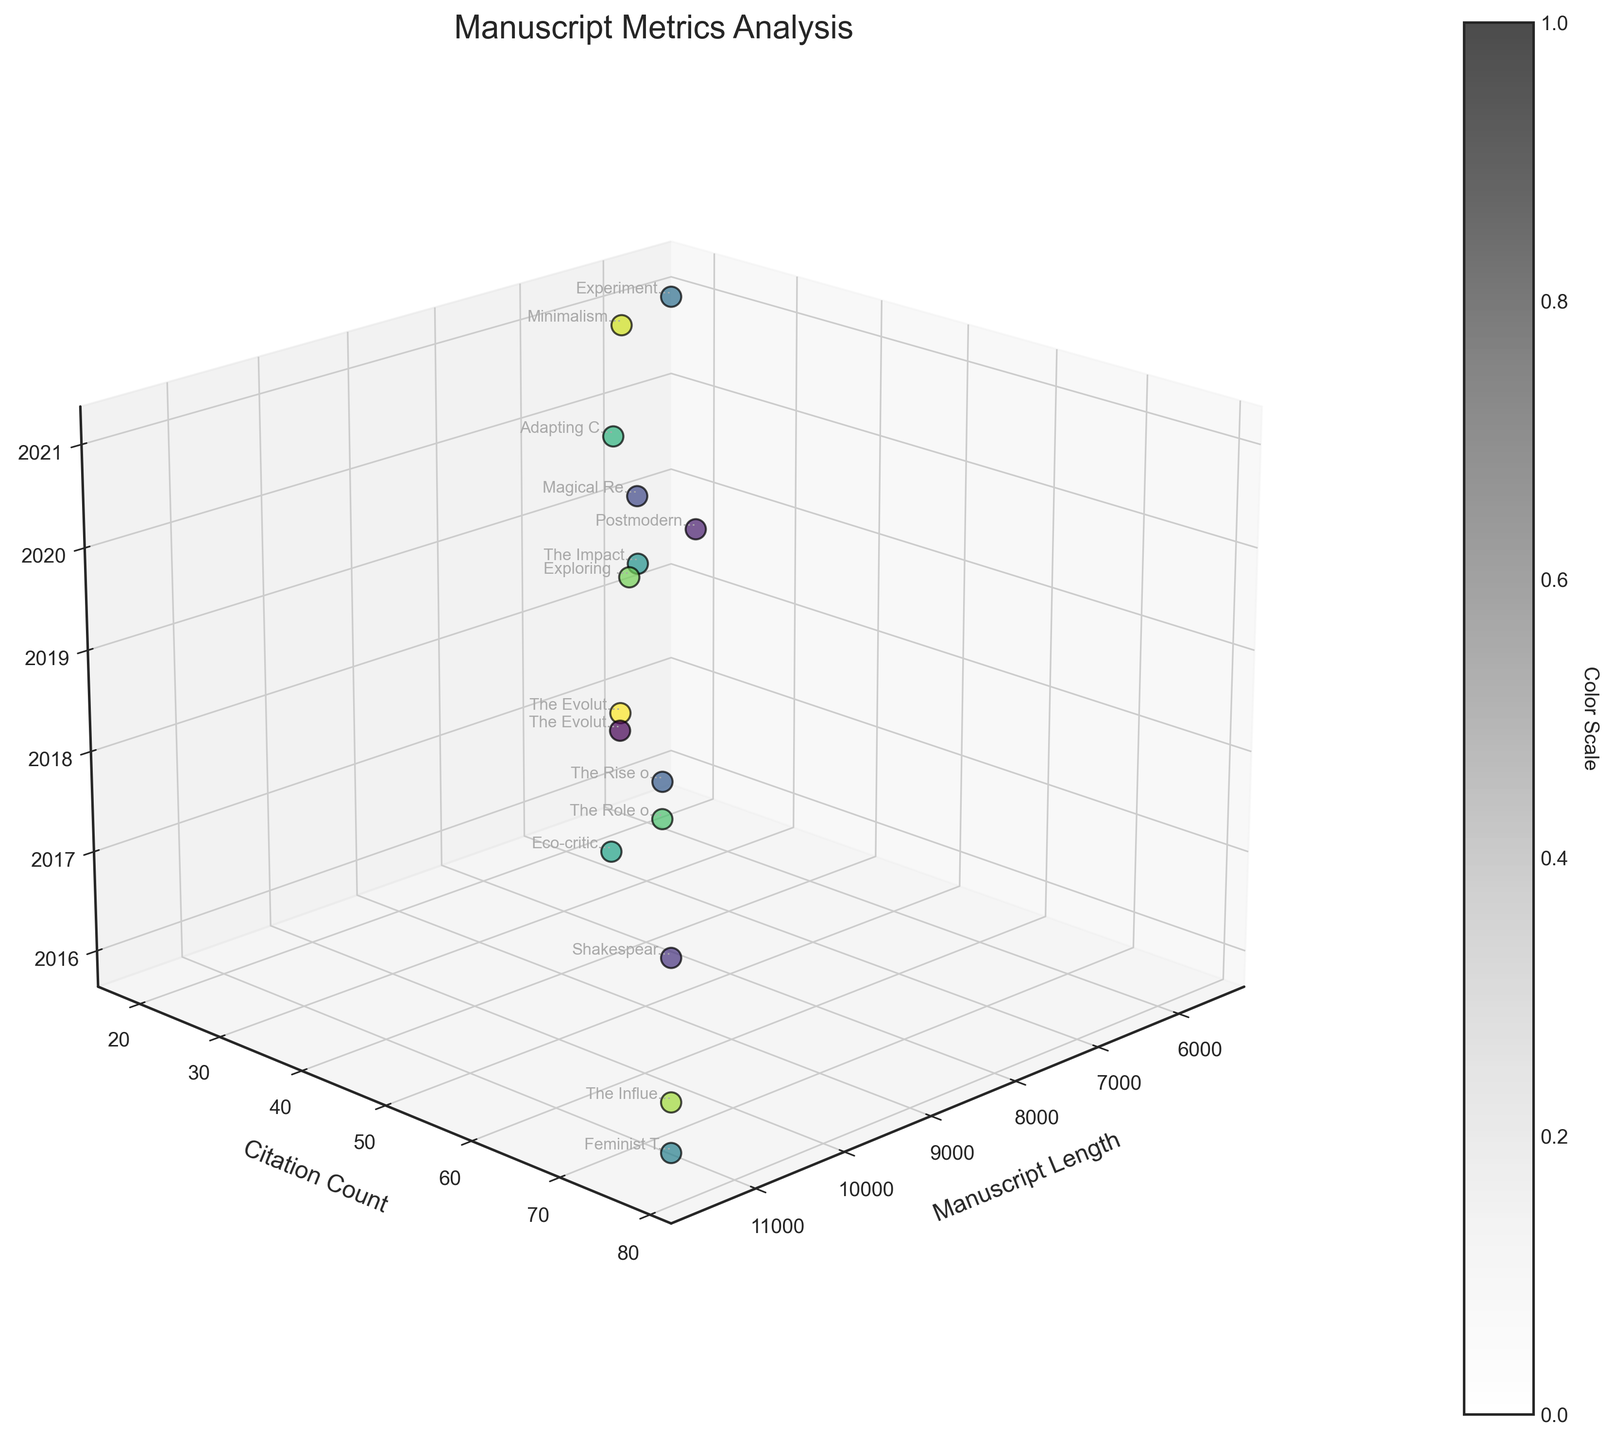What is the title of the figure? The title is placed at the top center of the figure and reads "Manuscript Metrics Analysis".
Answer: Manuscript Metrics Analysis How many data points are represented in the plot? Each data point corresponds to one of the manuscripts listed in the data, and there are 15 different manuscripts.
Answer: 15 What are the three axes in the plot? The three axes are labeled as follows: the x-axis is "Manuscript Length", the y-axis is "Citation Count", and the z-axis is "Publication Year".
Answer: Manuscript Length, Citation Count, Publication Year Which data point (manuscript) has the highest citation count? By observing the y-axis values and reading labels near the data points, the manuscript titled "Feminist Themes in 20th Century Poetry" has the highest citation count of 78.
Answer: Feminist Themes in 20th Century Poetry Compare the manuscript lengths of the two most recent publications. The two most recent publications are from 2021, titled "Experimental Narratives in Digital Storytelling" and "Minimalism in Short Story Writing". Their lengths are 5600 and 6500 respectively. The length of "Minimalism in Short Story Writing" is 6500, which is longer.
Answer: Minimalism in Short Story Writing Is there a trend of increasing citation count with manuscript length? By observing the scatter of points in the plot, there doesn't appear to be a consistent trend that shows citation count increases with manuscript length. Some of the longer manuscripts have lower citation counts, and some shorter manuscripts have relatively high citation counts.
Answer: No consistent trend What is the average manuscript length for the manuscripts published in 2018? The manuscripts published in 2018 have lengths of 8500, 9100, 9700, and 8200. The average is calculated as (8500 + 9100 + 9700 + 8200)/4 = 8875.
Answer: 8875 Which manuscript has the earliest publication year and what is its length? The manuscript titled "Feminist Themes in 20th Century Poetry" was published in 2016 and has a manuscript length of 11500.
Answer: Feminist Themes in 20th Century Poetry, 11500 What is the color scale representing in the plot, and how is it useful? The color scale visualizes the range of publication years, providing an additional dimension to understand how metrics vary across different years. Darker colors represent earlier years, while lighter colors represent more recent years.
Answer: Publication Year Compare the citation counts for manuscripts published in 2017 with those published in 2019. Which year has a higher total citation count? The manuscripts published in 2017 are "Shakespeare's Influence on Modern Drama" with 65 citations and "Eco-criticism in Contemporary Nature Writing" with 45 citations, totaling 65 + 45 = 110. Manuscripts from 2019 have "Postmodern Techniques in Contemporary Fiction" with 28 citations, "The Impact of Social Media on Creative Writing" with 31 citations, and "Exploring Cultural Identity in Diaspora Literature" with 33 citations, totaling 28 + 31 + 33 = 92. Therefore, 2017 has a higher total citation count.
Answer: 2017 